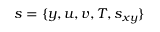Convert formula to latex. <formula><loc_0><loc_0><loc_500><loc_500>s = \{ y , u , v , T , s _ { x y } \}</formula> 